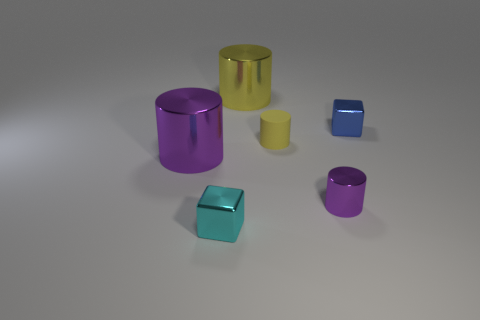Are there any other things that have the same material as the tiny yellow thing?
Ensure brevity in your answer.  No. What number of balls are large shiny objects or tiny yellow things?
Ensure brevity in your answer.  0. There is a block that is the same material as the cyan object; what color is it?
Provide a succinct answer. Blue. There is a metallic block that is to the left of the blue metal object; is it the same size as the big yellow cylinder?
Make the answer very short. No. Does the big purple cylinder have the same material as the cylinder that is on the right side of the small yellow matte object?
Your answer should be compact. Yes. What color is the tiny metallic cube that is behind the cyan metal block?
Provide a short and direct response. Blue. There is a purple cylinder behind the small shiny cylinder; are there any tiny cubes that are behind it?
Offer a very short reply. Yes. Do the object in front of the tiny purple cylinder and the small cylinder in front of the yellow rubber cylinder have the same color?
Keep it short and to the point. No. How many small cylinders are behind the large yellow thing?
Your response must be concise. 0. How many blocks are the same color as the tiny rubber object?
Your response must be concise. 0. 